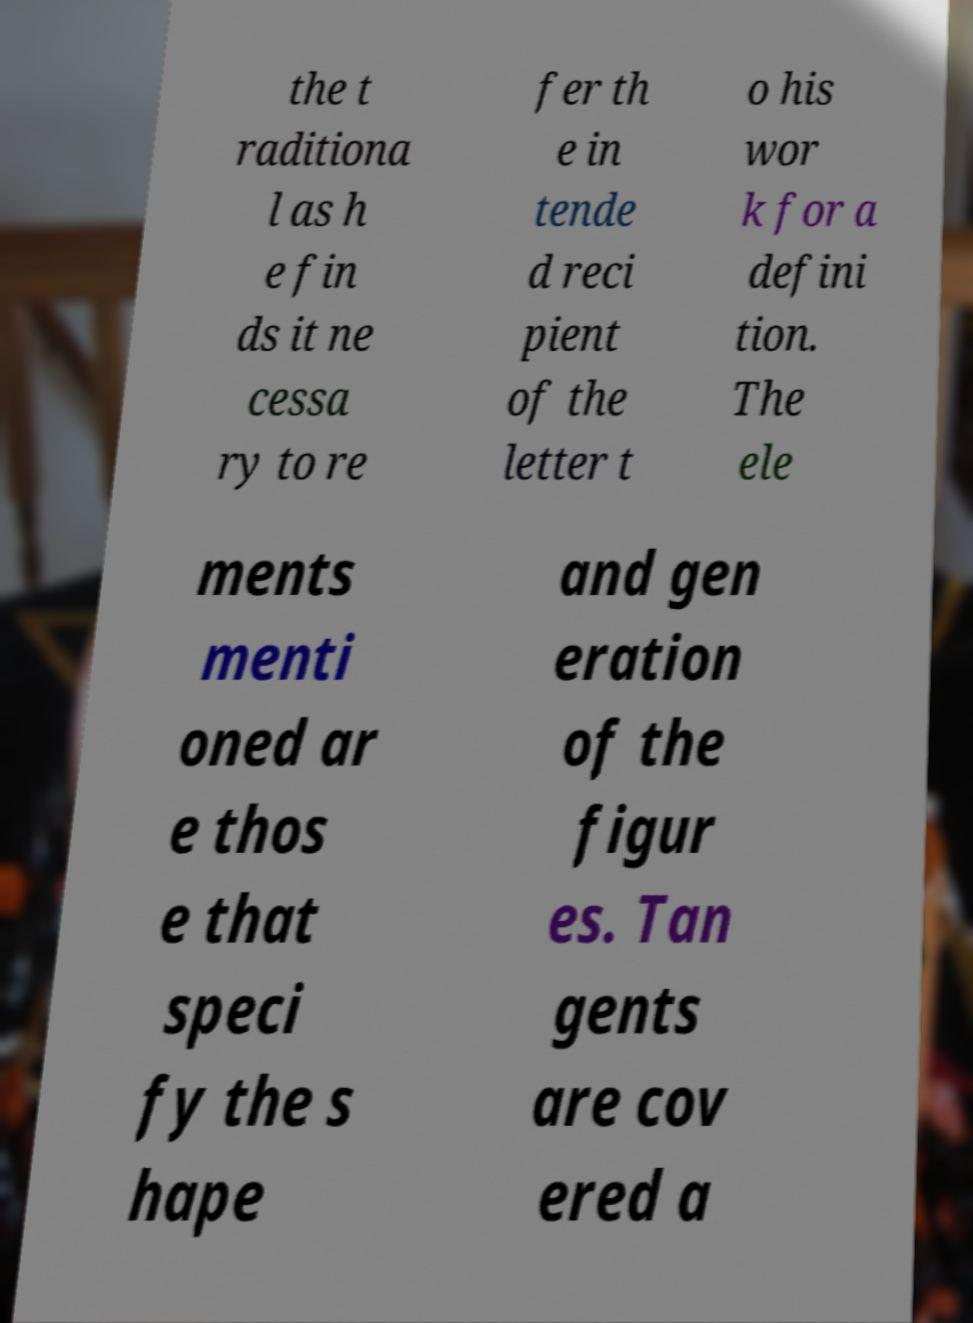Could you extract and type out the text from this image? the t raditiona l as h e fin ds it ne cessa ry to re fer th e in tende d reci pient of the letter t o his wor k for a defini tion. The ele ments menti oned ar e thos e that speci fy the s hape and gen eration of the figur es. Tan gents are cov ered a 